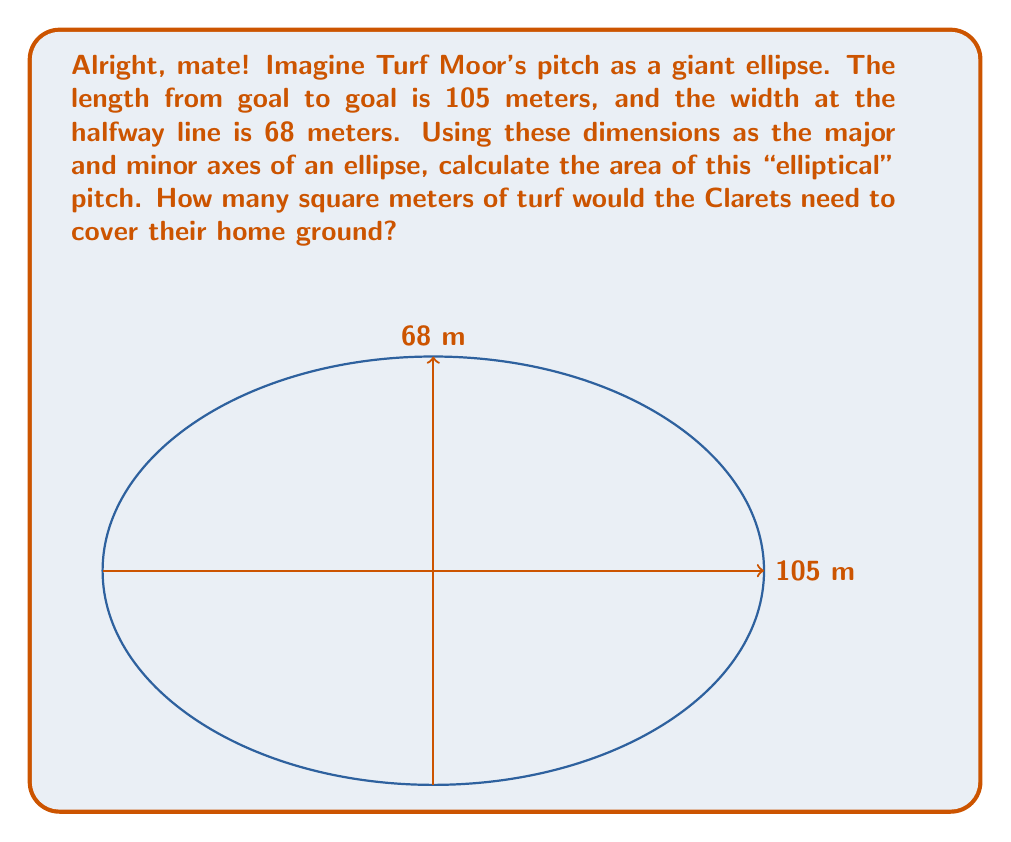Can you answer this question? Let's tackle this step-by-step, just like the Clarets breaking down a defense:

1) The area of an ellipse is given by the formula:

   $$A = \pi ab$$

   where $a$ and $b$ are the semi-major and semi-minor axes respectively.

2) We're given the full length and width, so we need to halve these to get the semi-axes:

   $a = 105/2 = 52.5$ meters
   $b = 68/2 = 34$ meters

3) Now let's substitute these into our formula:

   $$A = \pi (52.5)(34)$$

4) Let's calculate:

   $$A = \pi (1785)$$
   $$A = 5606.19... \text{ square meters}$$

5) Rounding to the nearest square meter:

   $$A \approx 5606 \text{ square meters}$$

So, the Clarets would need about 5606 square meters of turf to cover their "elliptical" pitch at Turf Moor.
Answer: $5606 \text{ m}^2$ 